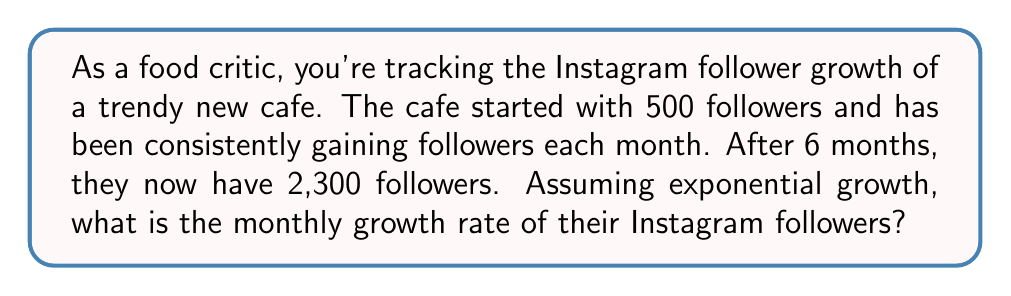Teach me how to tackle this problem. Let's approach this step-by-step:

1) We're dealing with exponential growth, which can be represented by the formula:

   $A = P(1+r)^t$

   Where:
   $A$ = Final amount
   $P$ = Initial amount
   $r$ = Growth rate (as a decimal)
   $t$ = Time periods

2) We know:
   $P = 500$ (initial followers)
   $A = 2300$ (final followers)
   $t = 6$ (months)

3) Let's plug these into our formula:

   $2300 = 500(1+r)^6$

4) Divide both sides by 500:

   $\frac{2300}{500} = (1+r)^6$

5) Simplify:

   $4.6 = (1+r)^6$

6) Take the 6th root of both sides:

   $\sqrt[6]{4.6} = 1+r$

7) Solve for $r$:

   $\sqrt[6]{4.6} - 1 = r$

8) Calculate:

   $r \approx 0.2884 - 1 = 0.2884 - 1 = 0.2884$

9) Convert to a percentage:

   $0.2884 \times 100\% = 28.84\%$

Thus, the monthly growth rate is approximately 28.84%.
Answer: 28.84% 